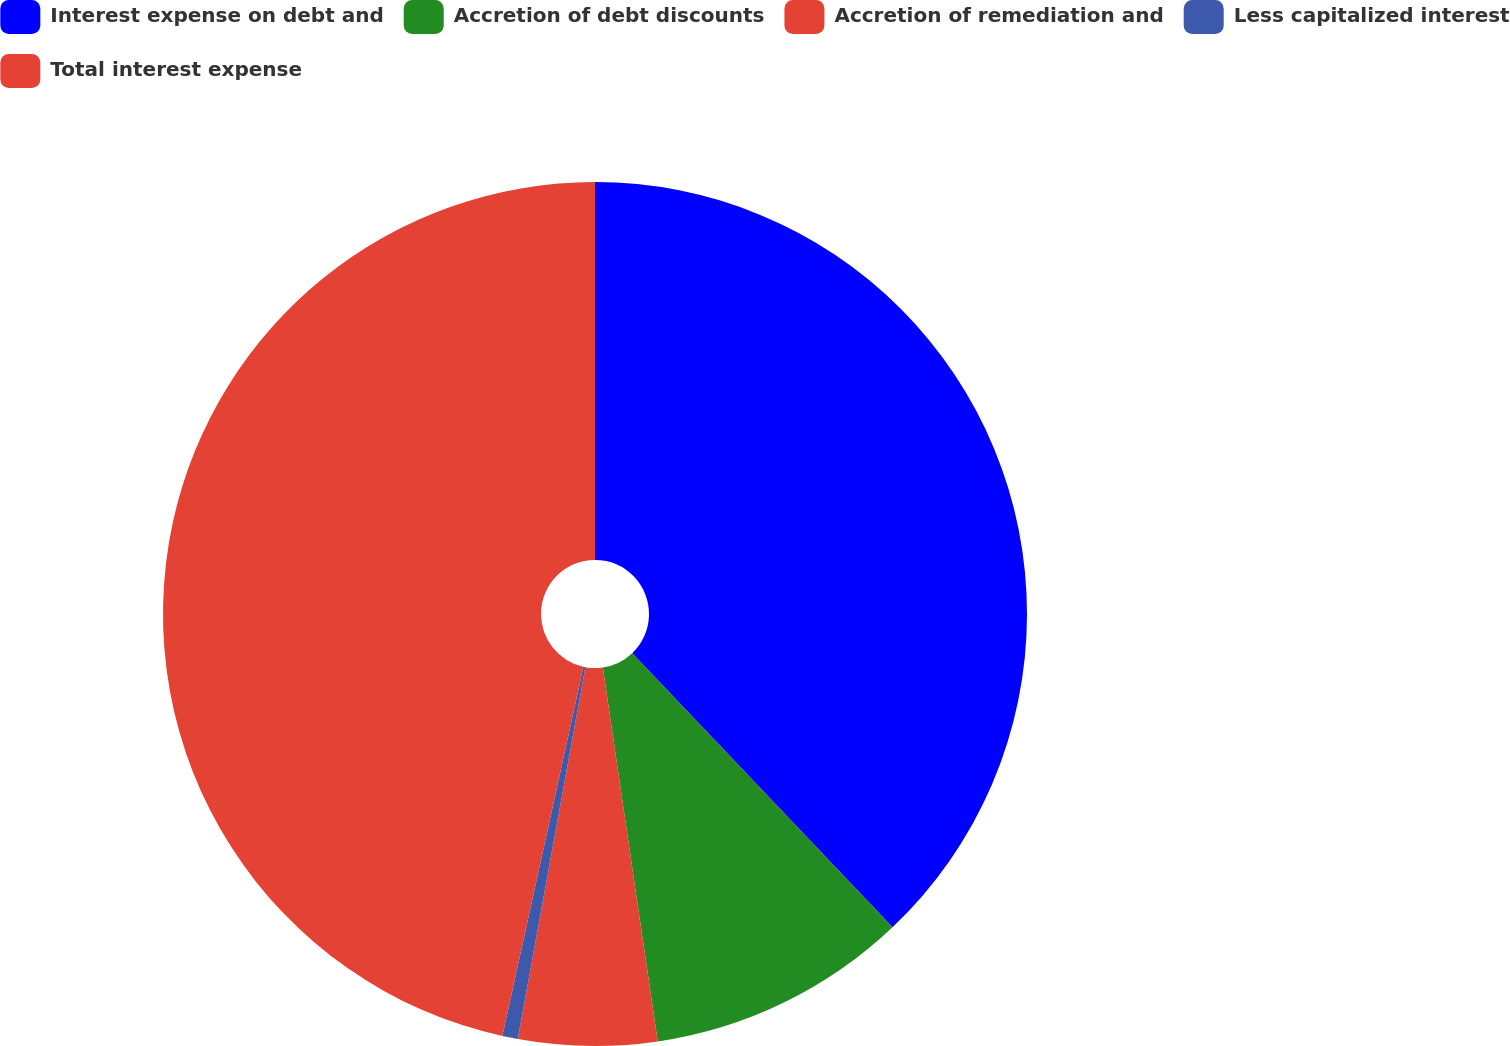Convert chart to OTSL. <chart><loc_0><loc_0><loc_500><loc_500><pie_chart><fcel>Interest expense on debt and<fcel>Accretion of debt discounts<fcel>Accretion of remediation and<fcel>Less capitalized interest<fcel>Total interest expense<nl><fcel>37.91%<fcel>9.77%<fcel>5.18%<fcel>0.58%<fcel>46.56%<nl></chart> 